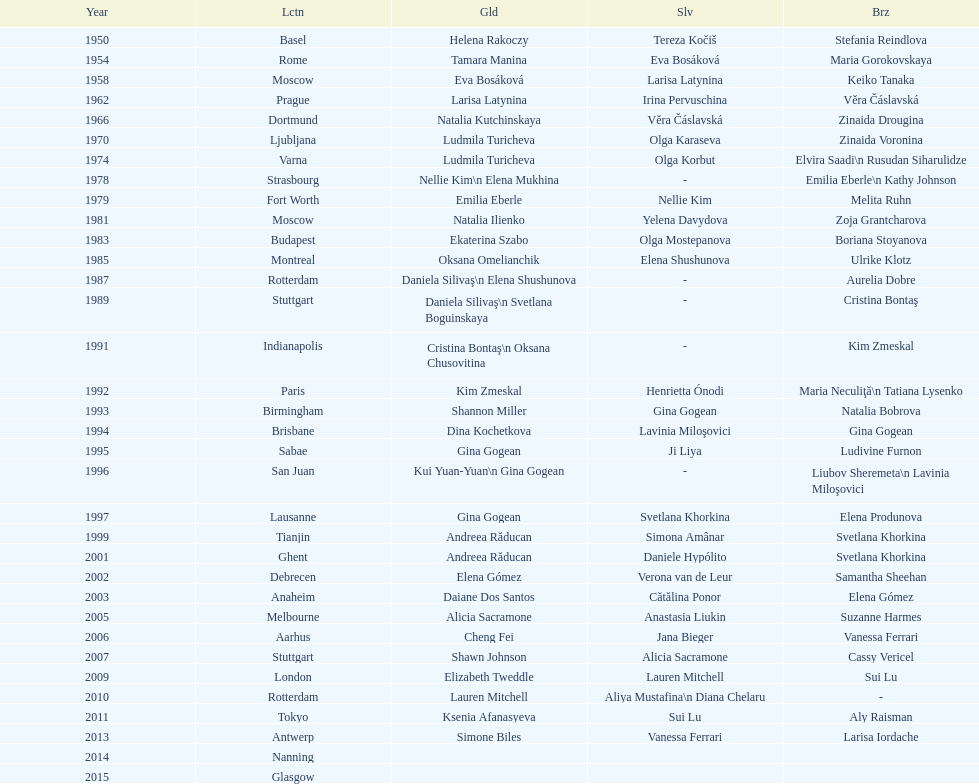How many times was the location in the united states? 3. 